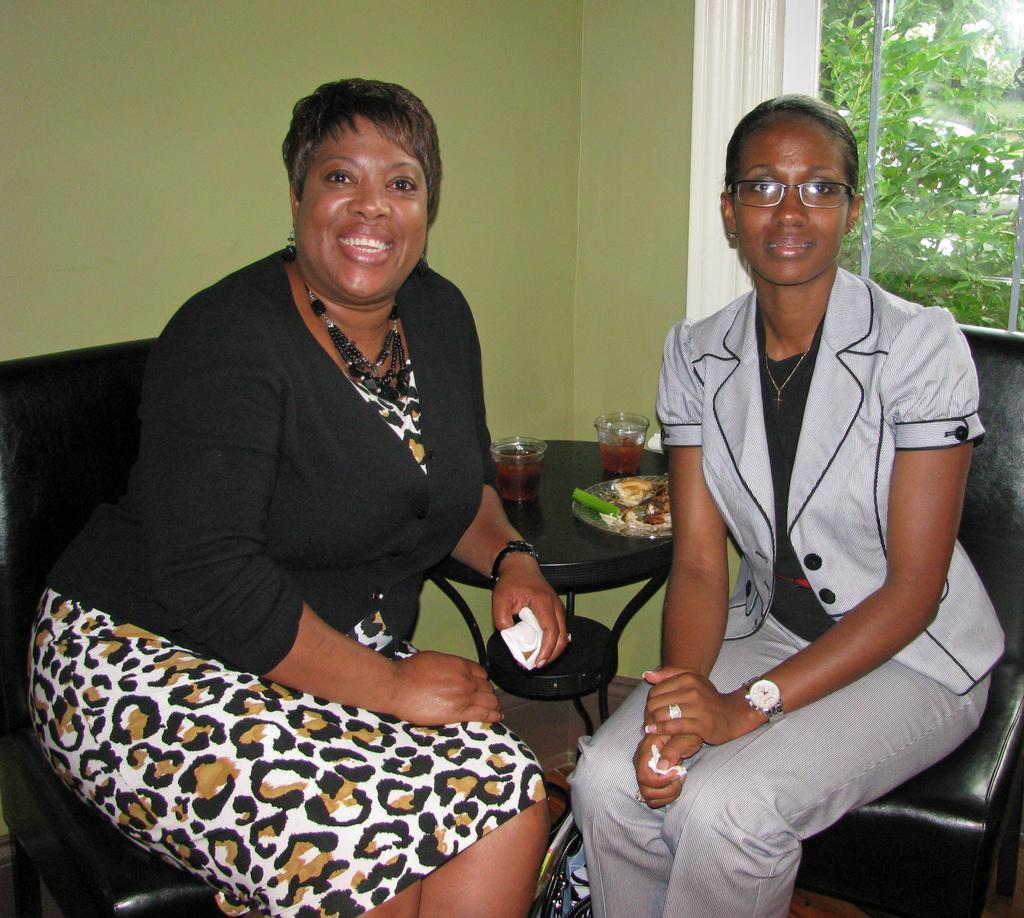Could you give a brief overview of what you see in this image? In this picture we can see two women, they are seated and smiling, beside to them we can find few glasses and a plate on the table, in the background we can see few trees. 